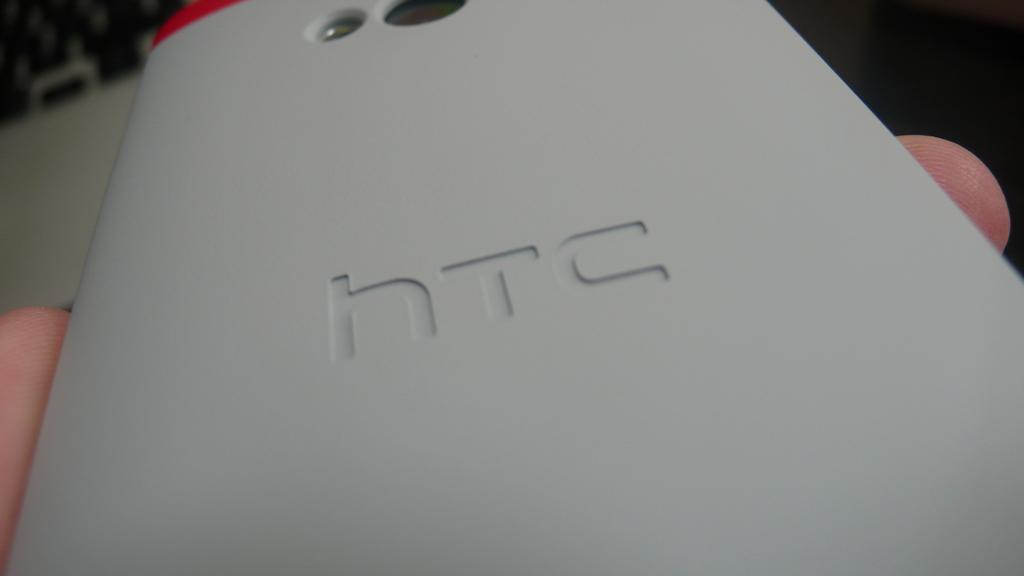<image>
Offer a succinct explanation of the picture presented. The back of an HTC phone with the camera lens and flash visible at the top. 